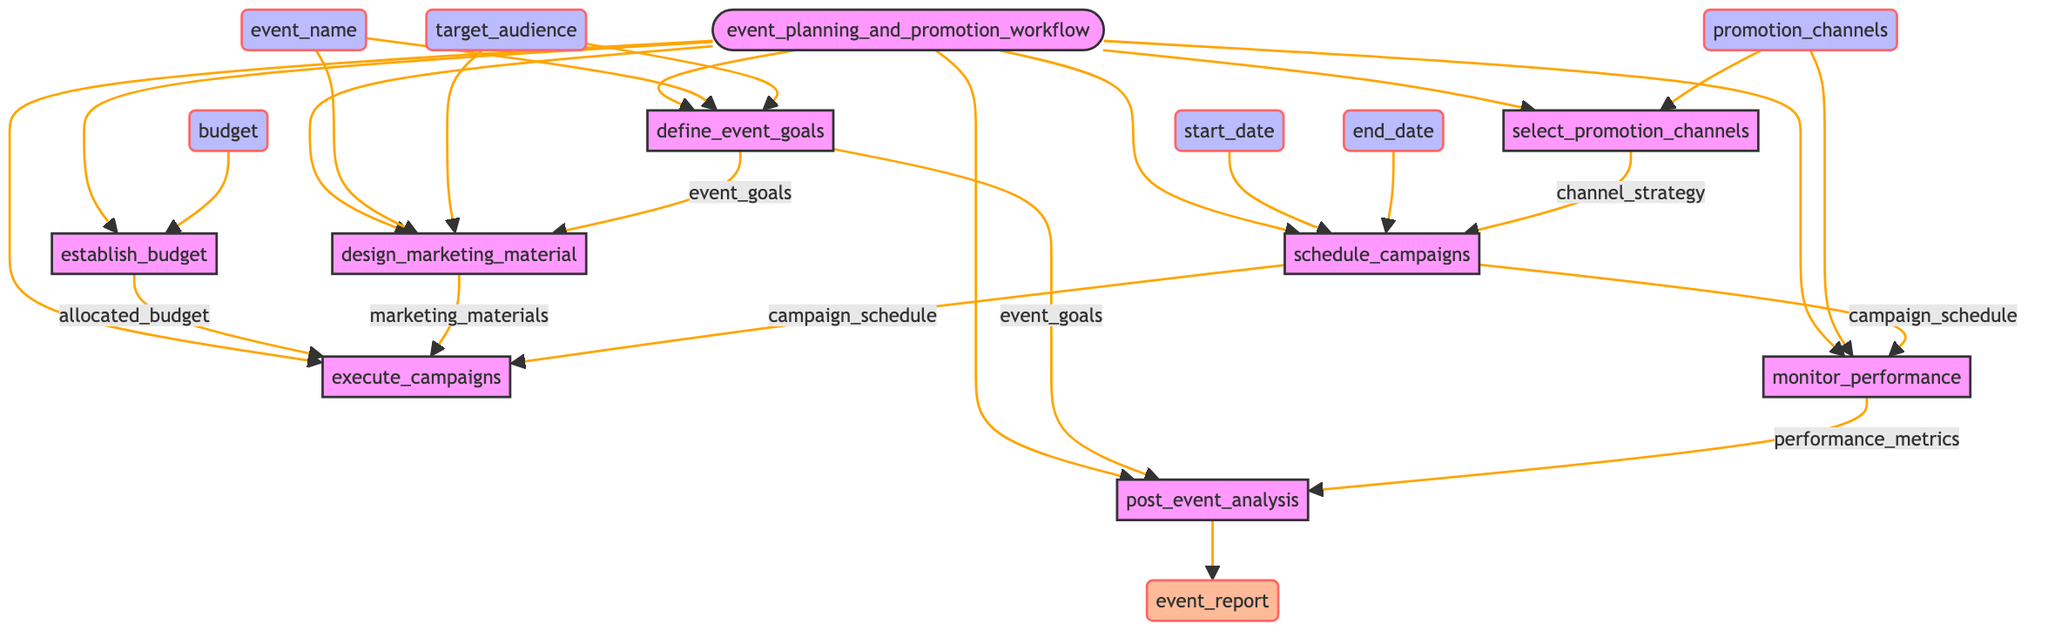what are the inputs to the event planning and promotion workflow? Based on the diagram, the inputs to the workflow include event_name, start_date, end_date, target_audience, budget, and promotion_channels. These are listed separately as input nodes that lead into the workflow.
Answer: event_name, start_date, end_date, target_audience, budget, promotion_channels how many steps are involved in the event planning and promotion workflow? The diagram shows a total of eight steps in the workflow: define_event_goals, establish_budget, design_marketing_material, select_promotion_channels, schedule_campaigns, execute_campaigns, monitor_performance, and post_event_analysis.
Answer: 8 which step directly leads to the execution of marketing campaigns? The step that directly leads to the execution of marketing campaigns is execute_campaigns. This step follows the scheduling of campaigns and is dependent on the campaign_schedule, marketing_materials, and allocated_budget.
Answer: execute_campaigns what outputs result from the monitor performance step? The output from the monitor performance step is performance_metrics. This is shown as the resulting output leading into the post_event_analysis step.
Answer: performance_metrics which steps utilize the input event_name? The steps that utilize the input event_name are define_event_goals and design_marketing_material. Both of these steps indicate that event_name is needed for their processes.
Answer: define_event_goals, design_marketing_material what happens after establishing the budget? After establishing the budget, the allocated_budget is used in the execute_campaigns step, indicating the connection between these two steps.
Answer: execute_campaigns how is the campaign schedule created? The campaign schedule is created in the schedule_campaigns step, which takes inputs from start_date, end_date, and channel_strategy, leading to the output of campaign_schedule.
Answer: schedule_campaigns which step is the final output of the workflow? The final output of the workflow is the event_report, which results from the post_event_analysis step, completing the workflow process.
Answer: event_report 